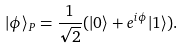<formula> <loc_0><loc_0><loc_500><loc_500>| \phi \rangle _ { P } = \frac { 1 } { \sqrt { 2 } } ( | 0 \rangle + e ^ { i \phi } | 1 \rangle ) .</formula> 